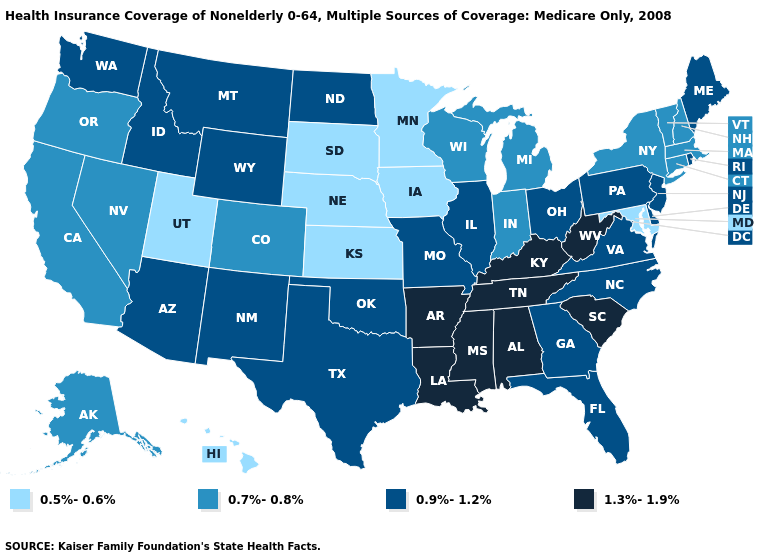Name the states that have a value in the range 0.5%-0.6%?
Give a very brief answer. Hawaii, Iowa, Kansas, Maryland, Minnesota, Nebraska, South Dakota, Utah. Name the states that have a value in the range 1.3%-1.9%?
Write a very short answer. Alabama, Arkansas, Kentucky, Louisiana, Mississippi, South Carolina, Tennessee, West Virginia. Which states have the lowest value in the South?
Answer briefly. Maryland. What is the lowest value in states that border Oregon?
Keep it brief. 0.7%-0.8%. Does Arkansas have the lowest value in the USA?
Be succinct. No. Name the states that have a value in the range 0.7%-0.8%?
Concise answer only. Alaska, California, Colorado, Connecticut, Indiana, Massachusetts, Michigan, Nevada, New Hampshire, New York, Oregon, Vermont, Wisconsin. Among the states that border Texas , which have the lowest value?
Write a very short answer. New Mexico, Oklahoma. What is the lowest value in the USA?
Concise answer only. 0.5%-0.6%. Does Kentucky have the highest value in the USA?
Keep it brief. Yes. Among the states that border Virginia , which have the lowest value?
Quick response, please. Maryland. What is the value of North Carolina?
Quick response, please. 0.9%-1.2%. Which states have the lowest value in the USA?
Be succinct. Hawaii, Iowa, Kansas, Maryland, Minnesota, Nebraska, South Dakota, Utah. Does North Dakota have the lowest value in the USA?
Keep it brief. No. What is the highest value in states that border West Virginia?
Write a very short answer. 1.3%-1.9%. Which states have the lowest value in the MidWest?
Quick response, please. Iowa, Kansas, Minnesota, Nebraska, South Dakota. 